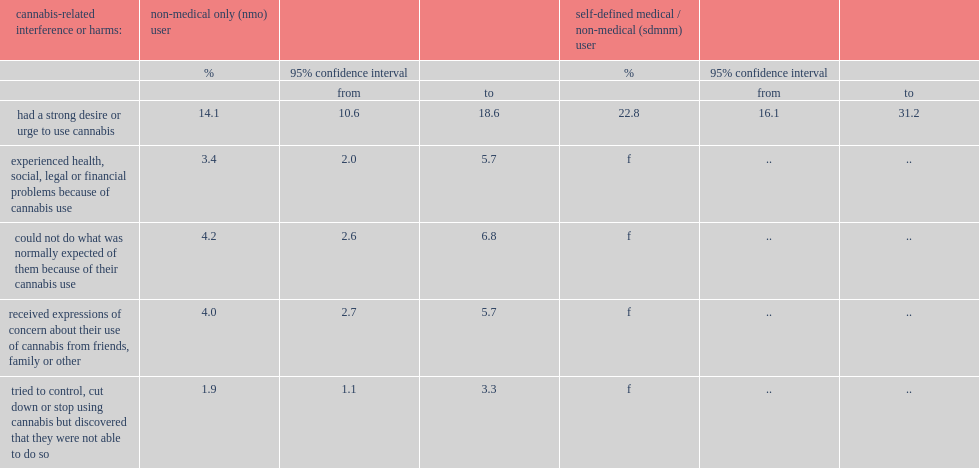What was the percentage of nmo users who had a strong desire or urge to use cannabis and sdmnm users respectively? 14.1 22.8. 